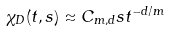Convert formula to latex. <formula><loc_0><loc_0><loc_500><loc_500>\chi _ { D } ( t , s ) \approx C _ { m , d } s t ^ { - d / m }</formula> 